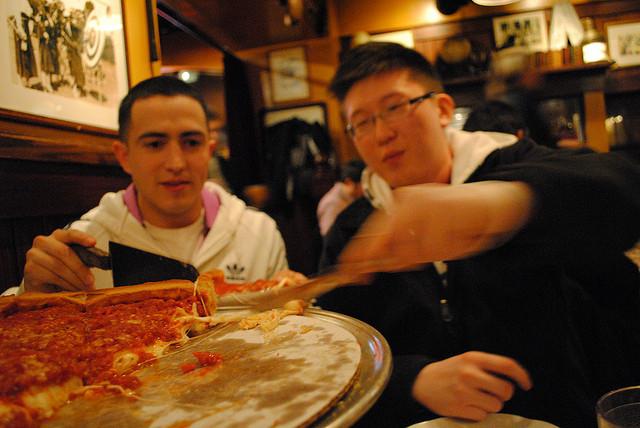Which hand is the man using to serve the food?
Write a very short answer. Left. How many slices are taken from the pizza?
Concise answer only. 4. What type of restaurant are they at?
Write a very short answer. Italian. Have people started eating yet?
Keep it brief. Yes. What is the man cutting the pizza with?
Quick response, please. Knife. How excited are the two customers to eat?
Short answer required. No. What is on the Asian man's eyes?
Write a very short answer. Glasses. 